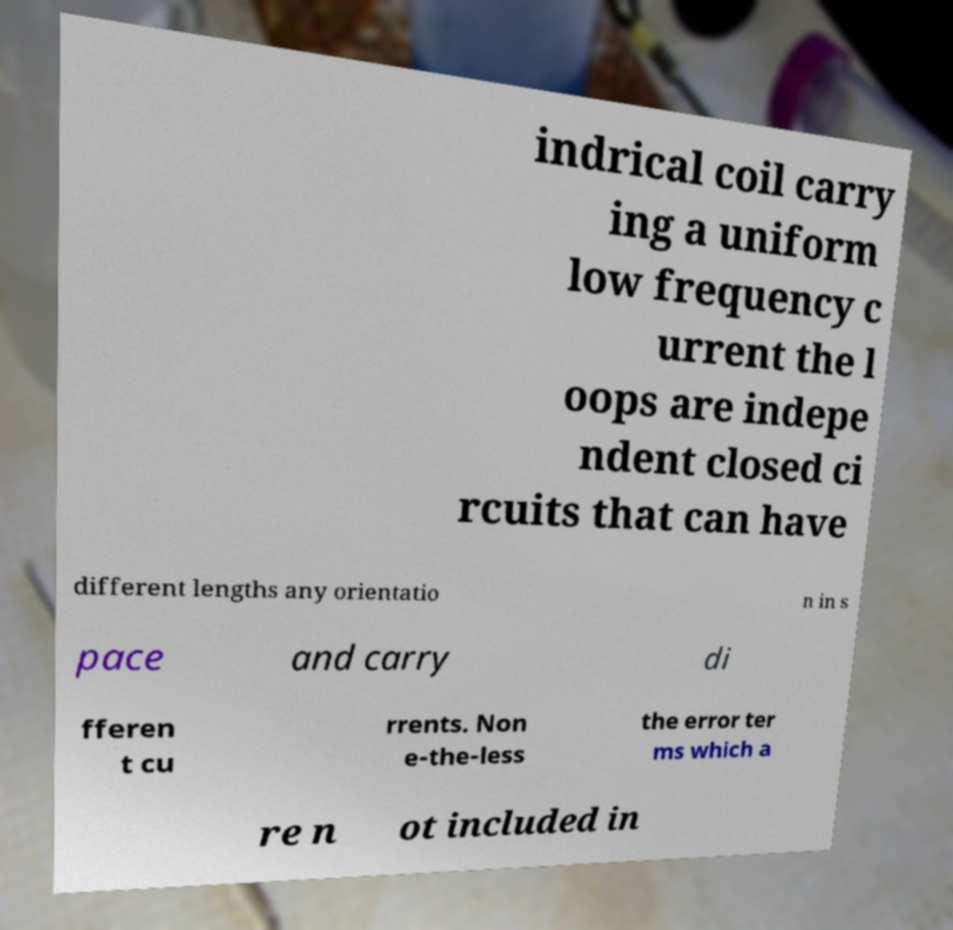Please read and relay the text visible in this image. What does it say? indrical coil carry ing a uniform low frequency c urrent the l oops are indepe ndent closed ci rcuits that can have different lengths any orientatio n in s pace and carry di fferen t cu rrents. Non e-the-less the error ter ms which a re n ot included in 